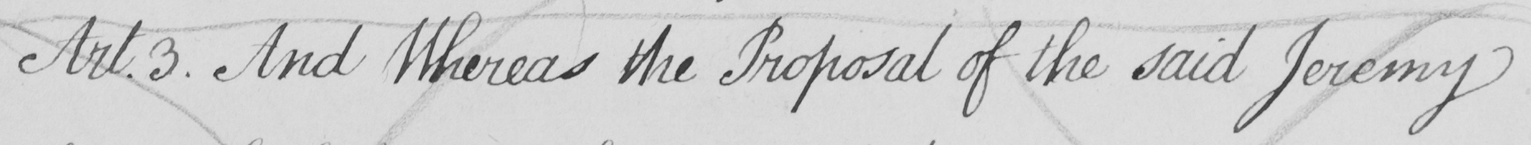What text is written in this handwritten line? Art . 3 . And Whereas the Proposal of the said Jeremy 